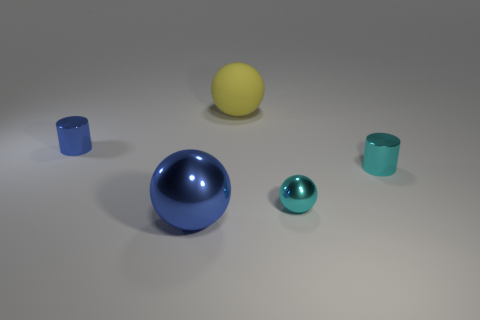How many large things are either blue metallic balls or gray cylinders?
Give a very brief answer. 1. Does the yellow sphere have the same size as the metallic ball that is to the right of the large blue metal ball?
Your response must be concise. No. Is there anything else that has the same shape as the small blue metal object?
Provide a succinct answer. Yes. What number of big green metal balls are there?
Make the answer very short. 0. How many red things are either rubber objects or tiny things?
Provide a short and direct response. 0. Are the cylinder that is right of the tiny blue metal cylinder and the big yellow sphere made of the same material?
Your answer should be very brief. No. How many other objects are there of the same material as the big blue ball?
Provide a succinct answer. 3. What material is the yellow sphere?
Offer a very short reply. Rubber. There is a metallic cylinder that is to the left of the big yellow thing; what is its size?
Ensure brevity in your answer.  Small. How many cyan balls are left of the thing that is in front of the cyan metallic sphere?
Provide a short and direct response. 0. 